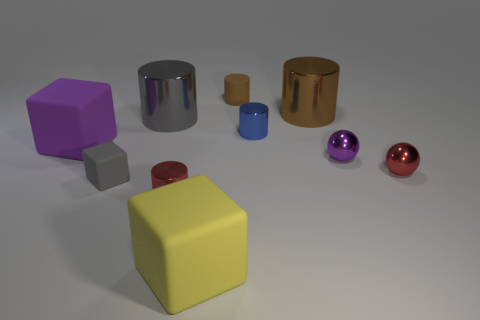Subtract all gray cylinders. How many cylinders are left? 4 Subtract all small brown rubber cylinders. How many cylinders are left? 4 Subtract all green cylinders. Subtract all blue spheres. How many cylinders are left? 5 Subtract all spheres. How many objects are left? 8 Add 1 tiny brown cylinders. How many tiny brown cylinders are left? 2 Add 5 purple matte objects. How many purple matte objects exist? 6 Subtract 0 green cylinders. How many objects are left? 10 Subtract all tiny gray objects. Subtract all brown metal blocks. How many objects are left? 9 